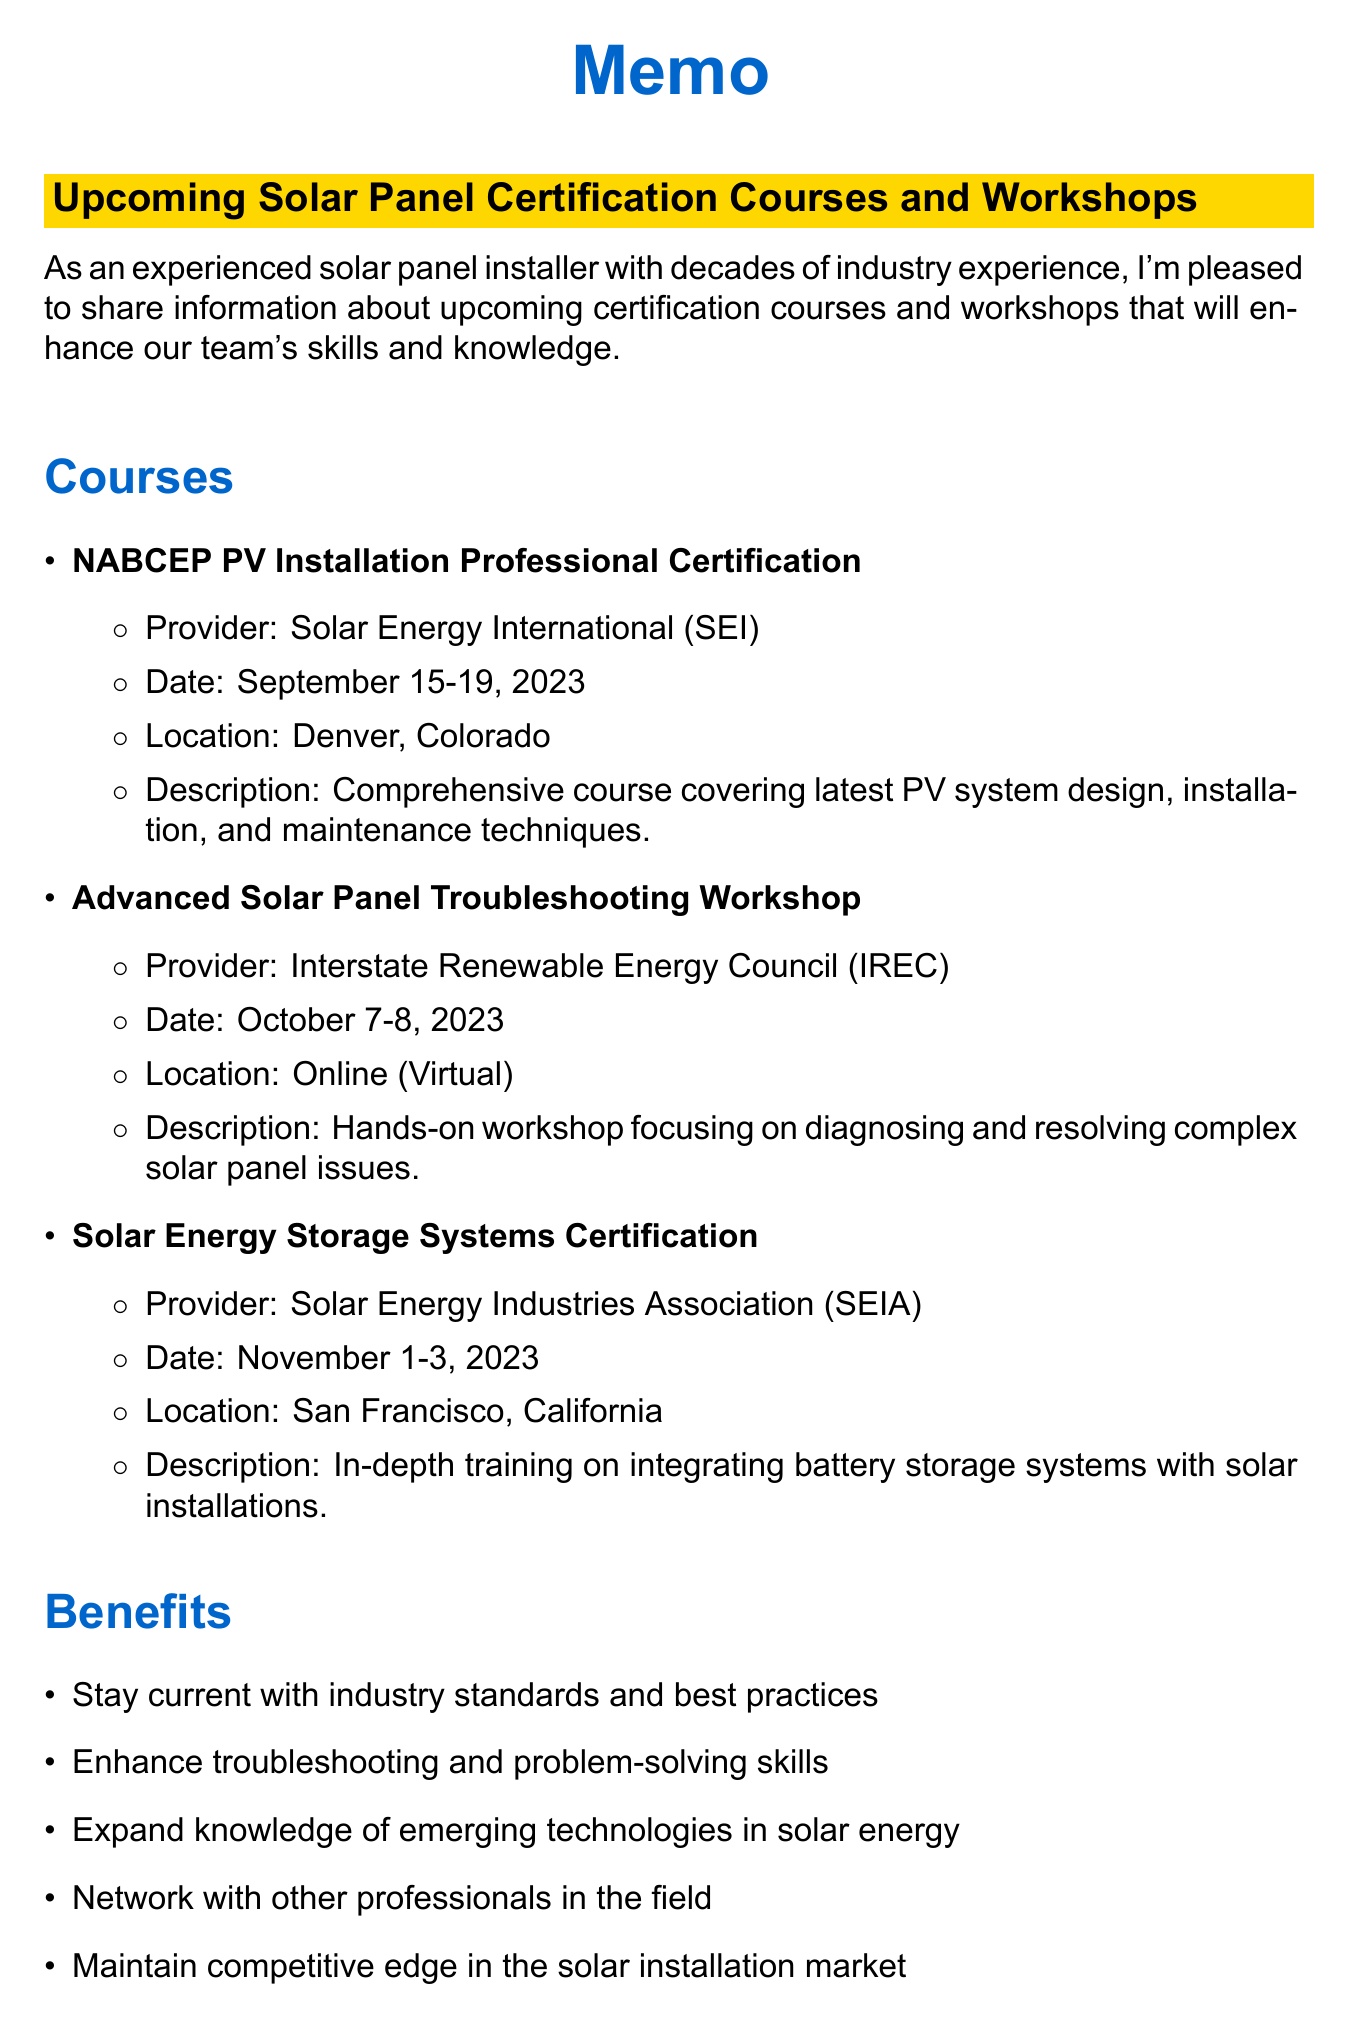what is the name of the first course listed? The first course listed is "NABCEP PV Installation Professional Certification."
Answer: NABCEP PV Installation Professional Certification what are the dates for the Advanced Solar Panel Troubleshooting Workshop? The dates for the workshop are provided in the document as October 7-8, 2023.
Answer: October 7-8, 2023 where is the Solar Energy Storage Systems Certification course located? The location for the certification course is mentioned in the document as San Francisco, California.
Answer: San Francisco, California who is the contact person for registration? The document specifies that Sarah Johnson is the contact person for registration.
Answer: Sarah Johnson what is the registration deadline for the courses? The registration deadline is explicitly stated in the document as August 31, 2023.
Answer: August 31, 2023 what percentage of course fees are covered by the company? The document indicates that 100% of course fees are covered for successful completion.
Answer: 100% what type of support is provided for attending in-person courses? The document mentions that paid time off is provided for attending in-person courses.
Answer: Paid time off why should team members attend these courses? The document lists multiple benefits, one being to enhance troubleshooting and problem-solving skills.
Answer: Enhance troubleshooting and problem-solving skills how many workshops or courses are mentioned in the document? The total number of courses and workshops listed can be counted from the document, which includes three courses.
Answer: 3 